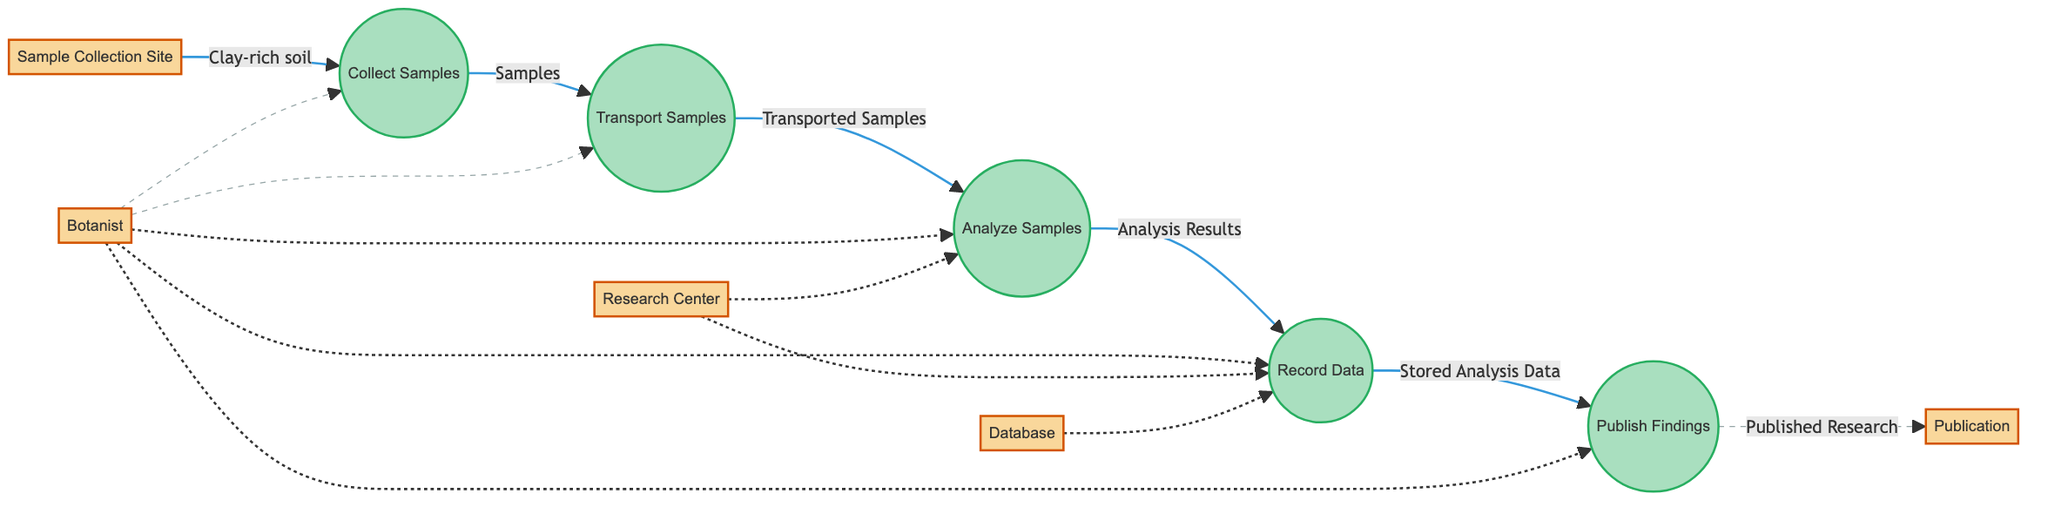What is the output of the "Collect Samples" process? The output of the "Collect Samples" process is labeled as "Samples," indicating that the process produces soil and plant samples from the collection site.
Answer: Samples How many processes are in the diagram? There are five processes depicted in the diagram: Collect Samples, Transport Samples, Analyze Samples, Record Data, and Publish Findings.
Answer: Five Which entity is responsible for analyzing the samples? The "Research Center," which is represented as the "Analytical Lab," is responsible for analyzing the transported samples, as denoted in the flow from "Transport Samples" to "Analyze Samples."
Answer: Research Center What is the input to the "Record Data" process? The input to the "Record Data" process is labeled as "Analysis Results," which indicates that the analysis outcomes are recorded in the data storage.
Answer: Analysis Results What is the final output of the process flow? The final output of the process flow is labeled as "Published Research," representing the findings published in a scientific journal.
Answer: Published Research How does the "Transport Samples" process relate to "Analyze Samples"? The "Transport Samples" process feeds its output, "Transported Samples," into the "Analyze Samples" process, establishing a direct connection in the flow of data from one process to another.
Answer: Transported Samples Which process directly records the analysis results? The "Record Data" process directly records the analysis results, as indicated by its input being "Analysis Results" from the "Analyze Samples" process.
Answer: Record Data What is the role of the "Botanist" in this diagram? The "Botanist" is a field researcher who initiates the "Collect Samples" process and has a role in all stages, facilitating the overall study of plant-soil interactions.
Answer: Field Researcher What is the relationship between "Stored Analysis Data" and "Published Research"? "Stored Analysis Data" is the input for the "Publish Findings" process, which produces "Published Research," showing the flow of information from storage to publication.
Answer: Publish Findings 